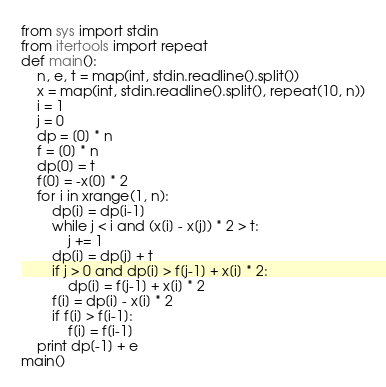Convert code to text. <code><loc_0><loc_0><loc_500><loc_500><_Python_>from sys import stdin
from itertools import repeat
def main():
    n, e, t = map(int, stdin.readline().split())
    x = map(int, stdin.readline().split(), repeat(10, n))
    i = 1
    j = 0
    dp = [0] * n
    f = [0] * n
    dp[0] = t
    f[0] = -x[0] * 2
    for i in xrange(1, n):
        dp[i] = dp[i-1]
        while j < i and (x[i] - x[j]) * 2 > t:
            j += 1
        dp[i] = dp[j] + t
        if j > 0 and dp[i] > f[j-1] + x[i] * 2:
            dp[i] = f[j-1] + x[i] * 2
        f[i] = dp[i] - x[i] * 2
        if f[i] > f[i-1]:
            f[i] = f[i-1]
    print dp[-1] + e
main()
</code> 